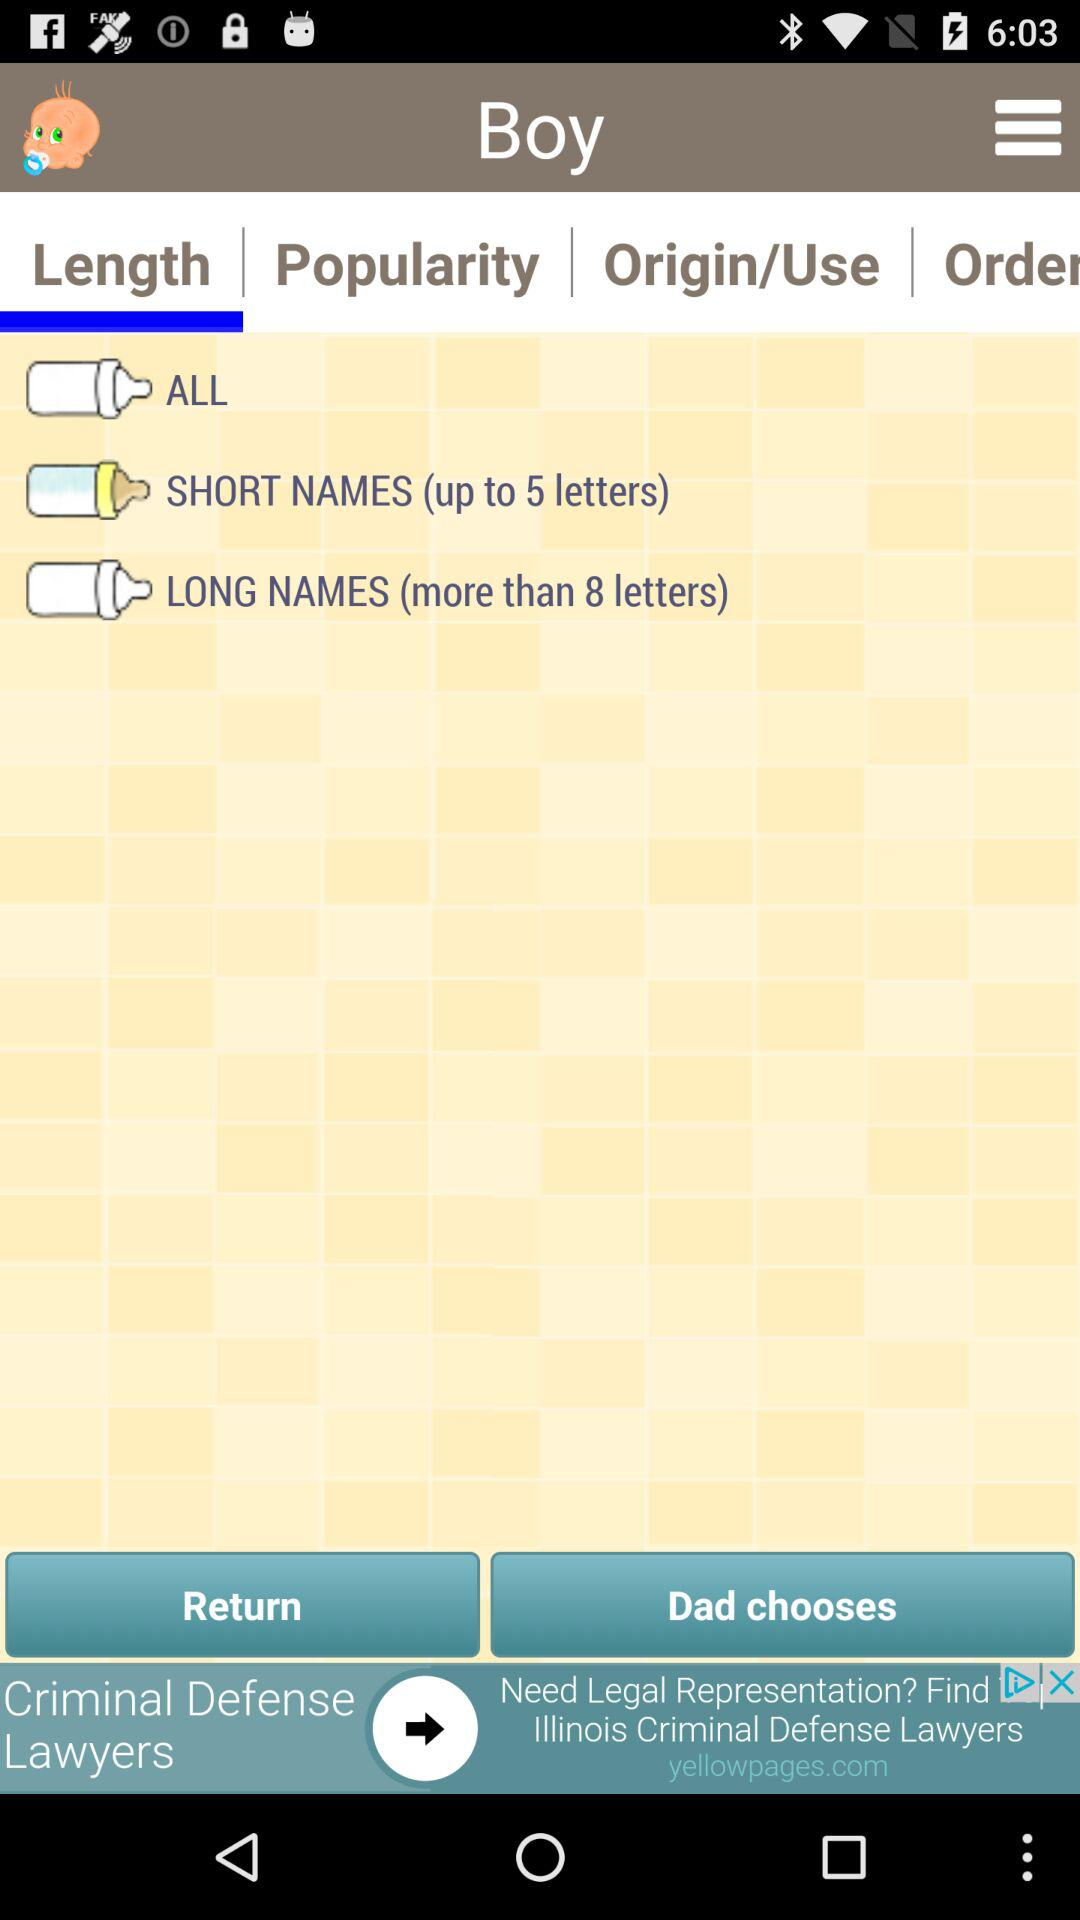Which option is selected for "Length" category? The selected option is "SHORT NAMES (up to 5 letters)". 